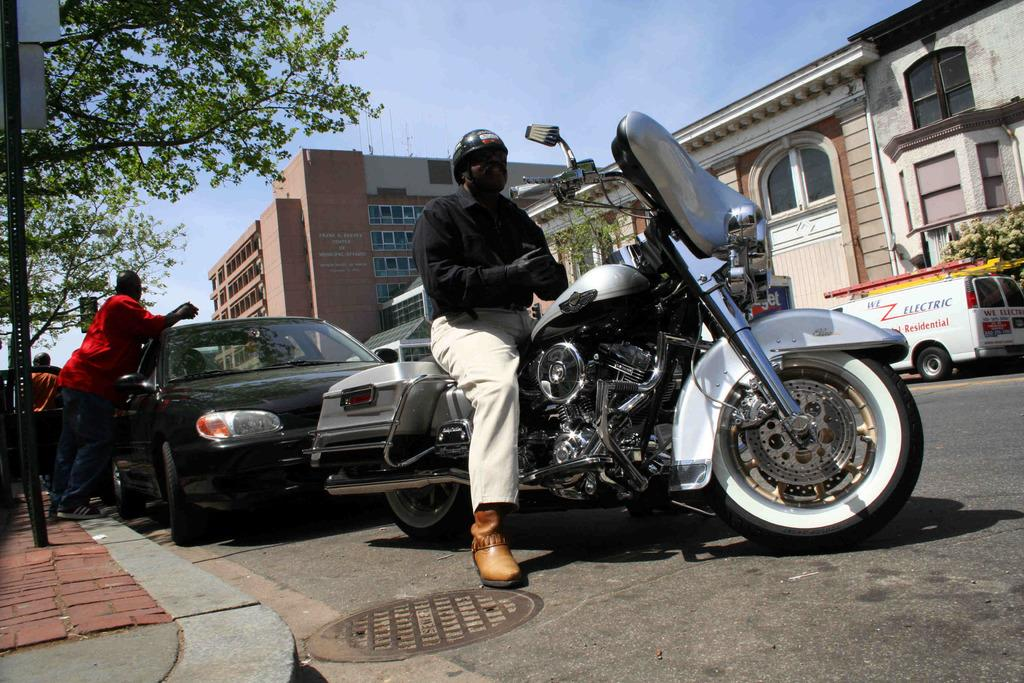What is the man in the image doing? The man is sitting on a motorbike. What safety precaution is the man taking in the image? The man is wearing a helmet. What can be seen in the background of the image? There are buildings with windows in the image. What type of transportation is present on the road? Vehicles are present on the road. Can you describe the person standing beside a vehicle? There is a person standing beside a vehicle, but no specific details about their appearance or actions are provided. What type of clouds can be seen in the image? There is no mention of clouds in the image; it features a man on a motorbike, buildings, and vehicles on the road. 